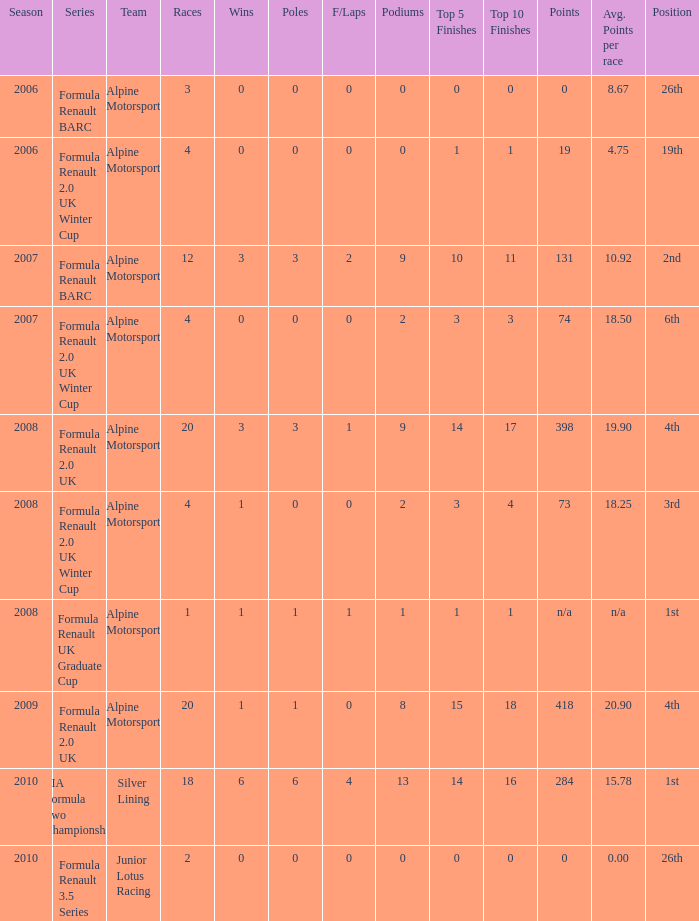How much were the f/laps if poles is higher than 1.0 during 2008? 1.0. 